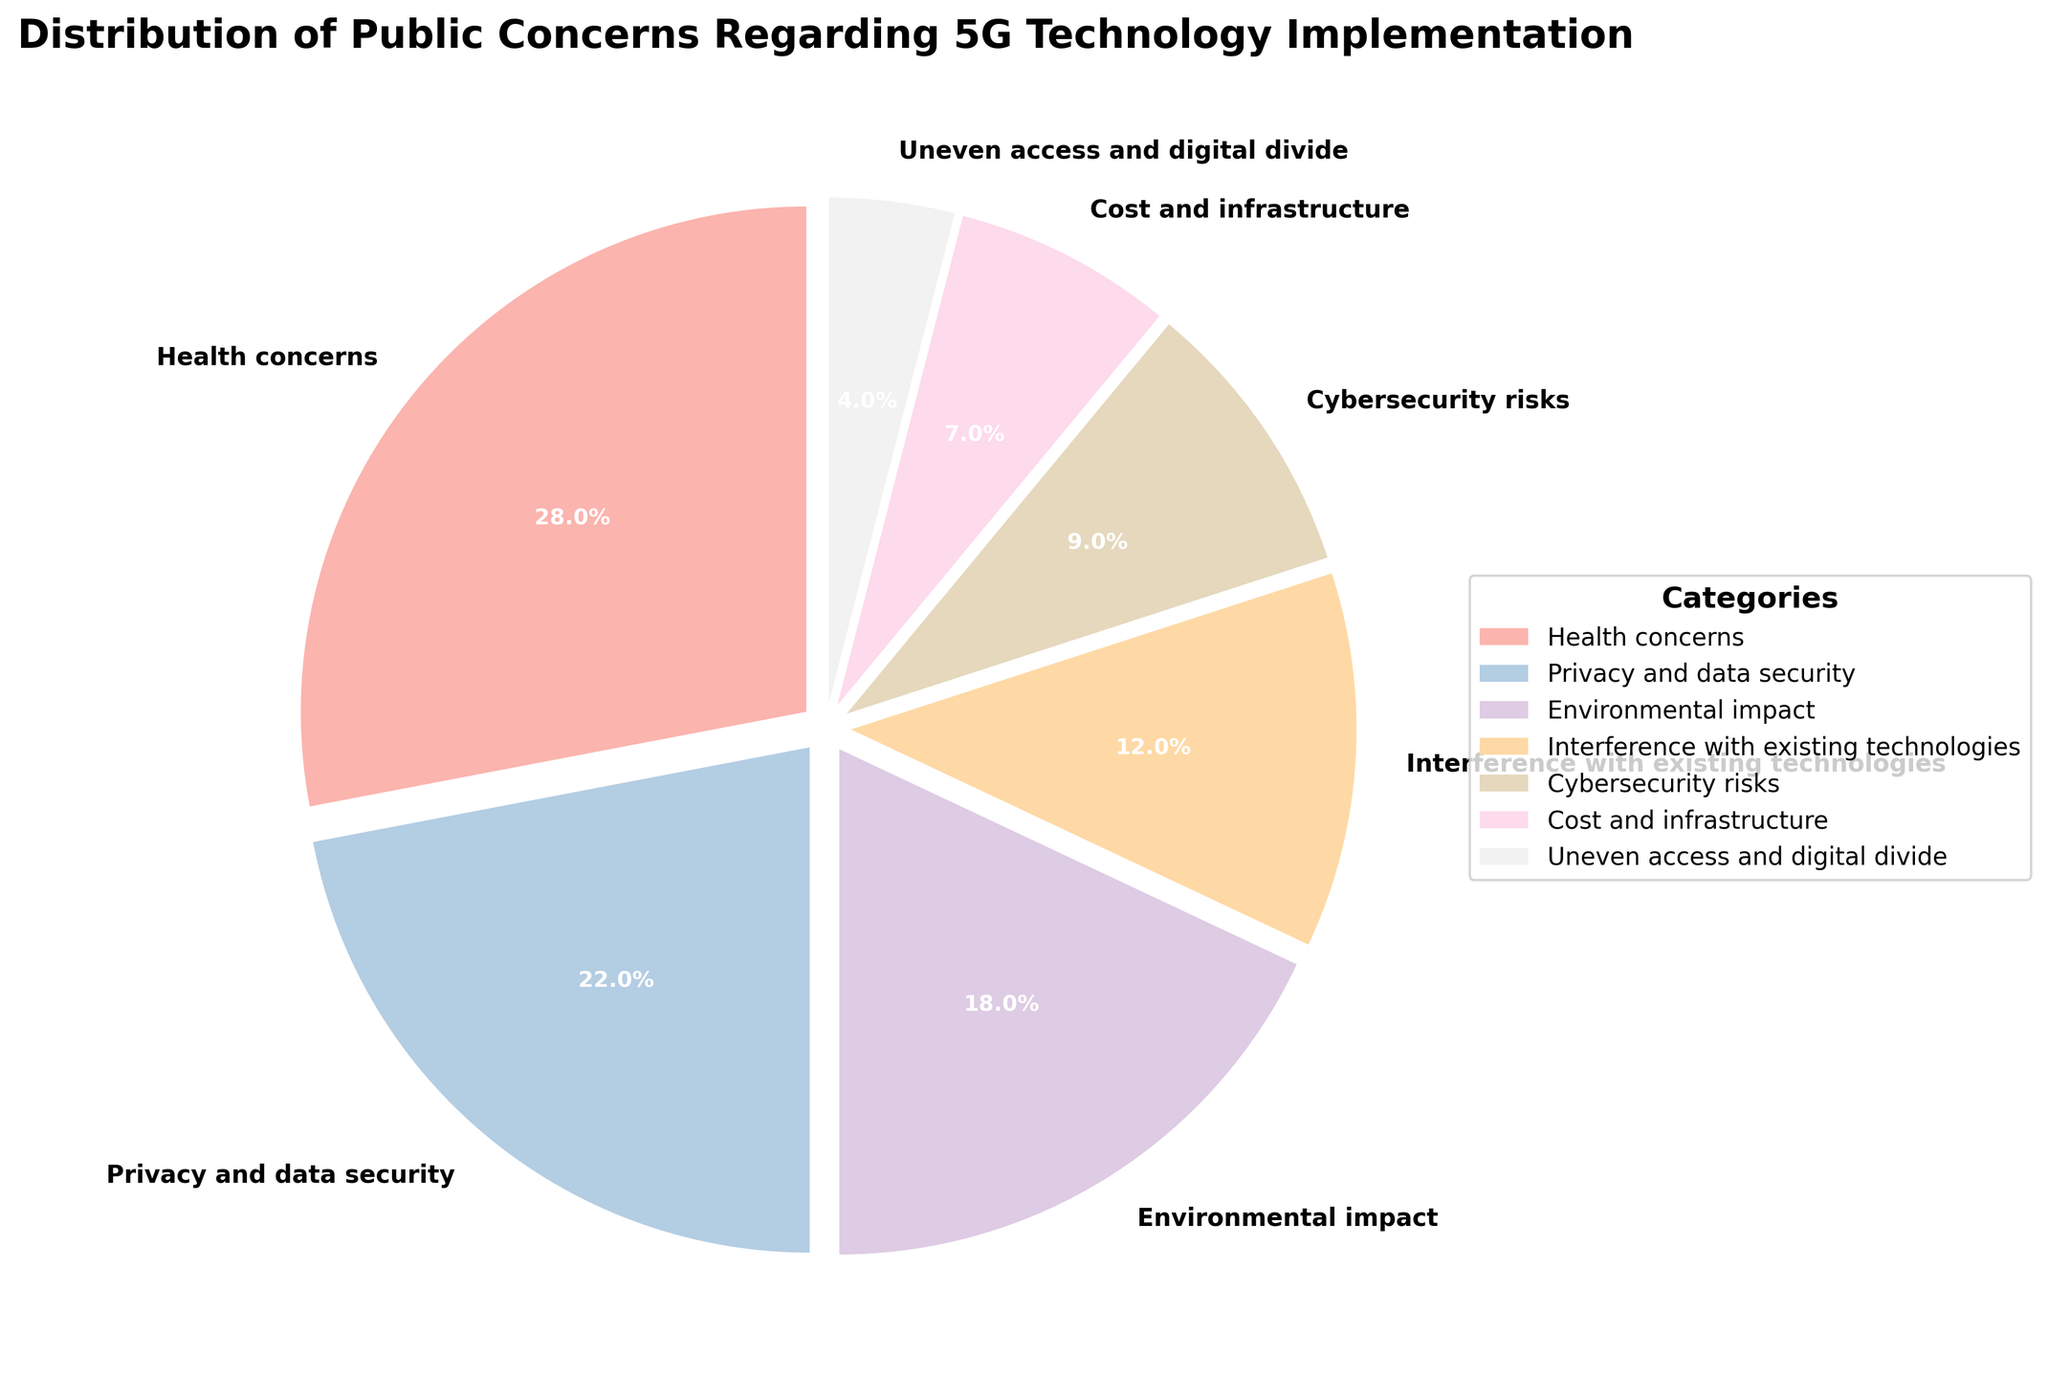What is the percentage of public concerns regarding privacy and data security? Locate the segment labeled "Privacy and data security" on the pie chart. The segment label shows the percentage, which is 22%.
Answer: 22% Which category has the highest percentage of public concerns? Identify the segment with the largest size visually. The segment labeled "Health concerns" appears the largest with 28%.
Answer: Health concerns What is the combined percentage of health concerns and privacy and data security concerns? Identify the percentages for "Health concerns" (28%) and "Privacy and data security" (22%). Add the two percentages: 28% + 22% = 50%.
Answer: 50% Which category has a smaller percentage of public concerns: interference with existing technologies or cost and infrastructure? Compare the segments labeled "Interference with existing technologies" (12%) and "Cost and infrastructure" (7%). The latter is smaller.
Answer: Cost and infrastructure What is the percentage difference between cybersecurity risks and environmental impact? Identify the percentages for "Cybersecurity risks" (9%) and "Environmental impact" (18%). Subtract the smaller from the larger: 18% - 9% = 9%.
Answer: 9% Which categories together make up less than 10% of the total public concerns? Identify categories with percentages less than 10%. Only "Uneven access and digital divide" with 4% fits the criteria.
Answer: Uneven access and digital divide What percentage of public concerns relates to cybersecurity issues? Locate the segment labeled "Cybersecurity risks" and note its percentage, which is 9%.
Answer: 9% Between health concerns and environmental impact, which has a greater percentage of public concerns? Compare the segments labeled "Health concerns" (28%) and "Environmental impact" (18%). "Health concerns" has the greater percentage.
Answer: Health concerns How does the concern about uneven access and digital divide compare to the concern about privacy and data security? Observe the segments labeled "Uneven access and digital divide" (4%) and "Privacy and data security" (22%). The latter is significantly higher.
Answer: Privacy and data security is higher What are the three least concerned categories and their combined percentage? Identify the three smallest segments: "Uneven access and digital divide" (4%), "Cost and infrastructure" (7%), and "Cybersecurity risks" (9%). Add these percentages: 4% + 7% + 9% = 20%.
Answer: Uneven access and digital divide, Cost and infrastructure, Cybersecurity risks; 20% 